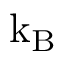Convert formula to latex. <formula><loc_0><loc_0><loc_500><loc_500>k _ { B }</formula> 